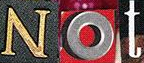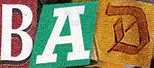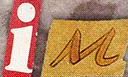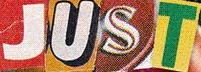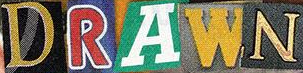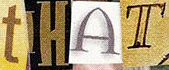What words can you see in these images in sequence, separated by a semicolon? Not; BAD; iM; JUST; DRAWN; tHAT 